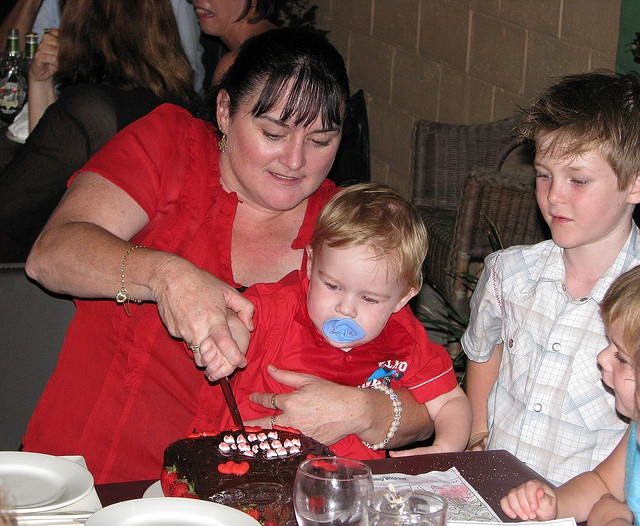Describe the objects in this image and their specific colors. I can see people in black, brown, and salmon tones, people in black, lightgray, lightpink, and darkgray tones, people in black, brown, lightpink, and maroon tones, people in black, maroon, and gray tones, and chair in black and gray tones in this image. 